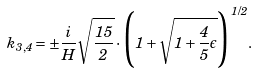<formula> <loc_0><loc_0><loc_500><loc_500>k _ { 3 , 4 } = \pm \frac { i } { H } \sqrt { \frac { 1 5 } { 2 } } \cdot \Big { ( } 1 + \sqrt { 1 + \frac { 4 } { 5 } \epsilon } \Big { ) } ^ { 1 / 2 } .</formula> 